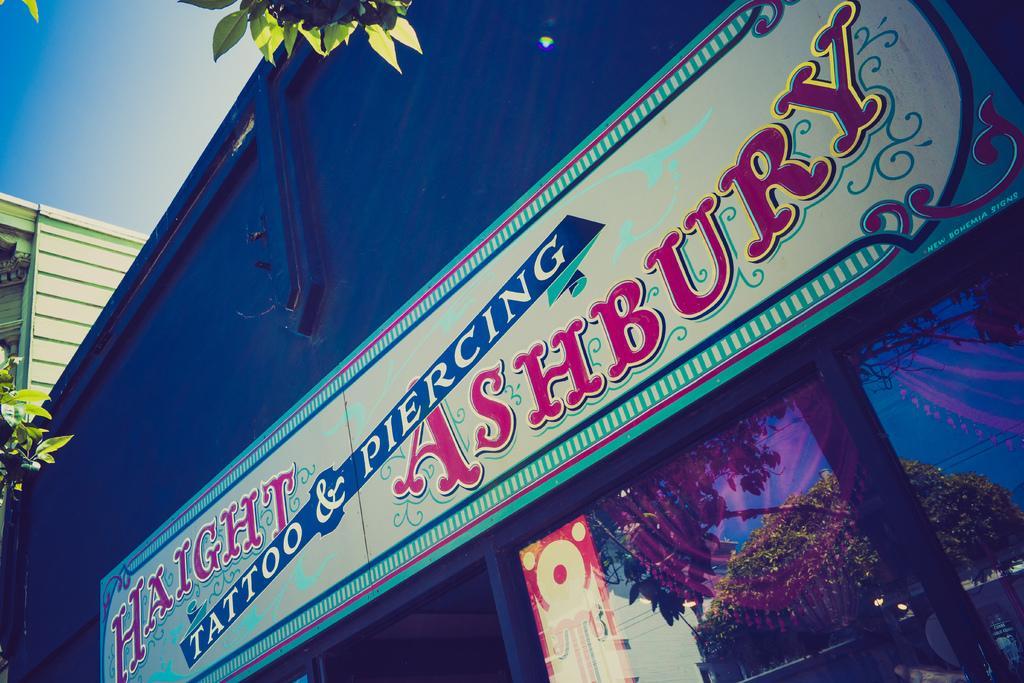Please provide a concise description of this image. At the top there is a sky. Here we can see green leaves. Here we can see there is something written. On the glass we can see the reflection of a tree and wires. 